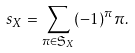<formula> <loc_0><loc_0><loc_500><loc_500>s _ { X } = \sum _ { \pi \in \mathfrak { S } _ { X } } ( - 1 ) ^ { \pi } \pi .</formula> 